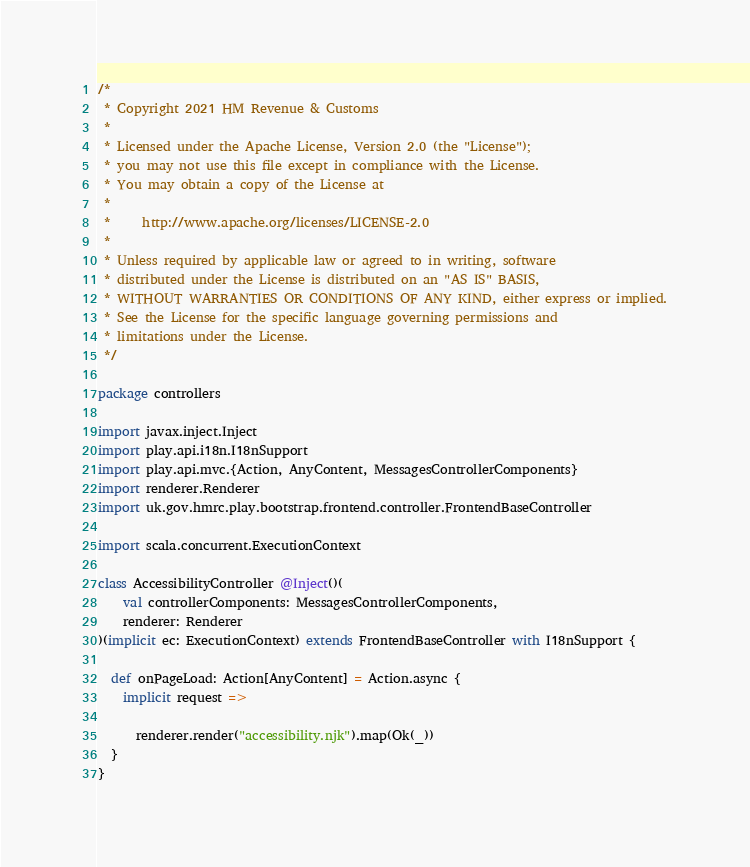<code> <loc_0><loc_0><loc_500><loc_500><_Scala_>/*
 * Copyright 2021 HM Revenue & Customs
 *
 * Licensed under the Apache License, Version 2.0 (the "License");
 * you may not use this file except in compliance with the License.
 * You may obtain a copy of the License at
 *
 *     http://www.apache.org/licenses/LICENSE-2.0
 *
 * Unless required by applicable law or agreed to in writing, software
 * distributed under the License is distributed on an "AS IS" BASIS,
 * WITHOUT WARRANTIES OR CONDITIONS OF ANY KIND, either express or implied.
 * See the License for the specific language governing permissions and
 * limitations under the License.
 */

package controllers

import javax.inject.Inject
import play.api.i18n.I18nSupport
import play.api.mvc.{Action, AnyContent, MessagesControllerComponents}
import renderer.Renderer
import uk.gov.hmrc.play.bootstrap.frontend.controller.FrontendBaseController

import scala.concurrent.ExecutionContext

class AccessibilityController @Inject()(
    val controllerComponents: MessagesControllerComponents,
    renderer: Renderer
)(implicit ec: ExecutionContext) extends FrontendBaseController with I18nSupport {

  def onPageLoad: Action[AnyContent] = Action.async {
    implicit request =>

      renderer.render("accessibility.njk").map(Ok(_))
  }
}
</code> 